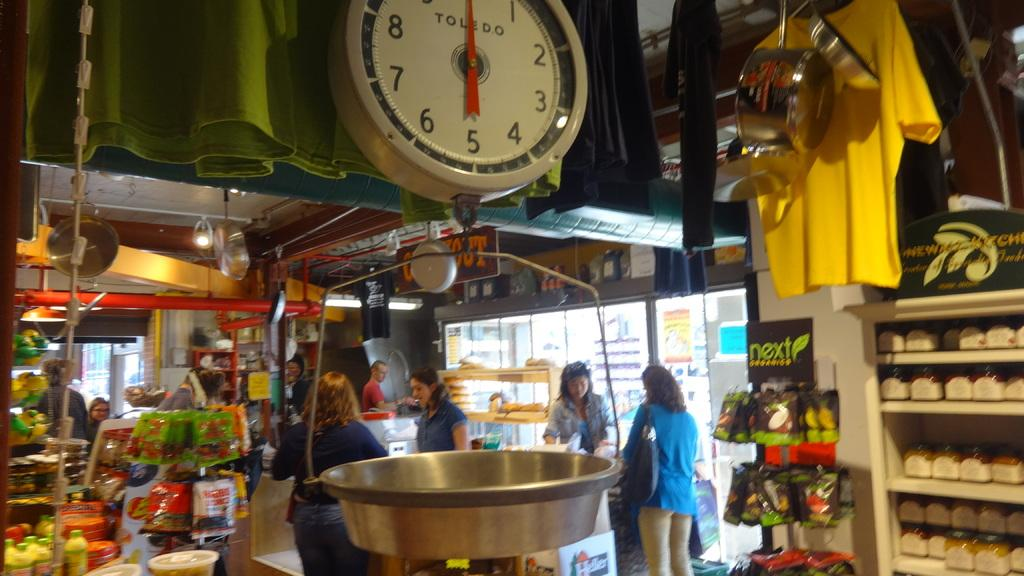<image>
Write a terse but informative summary of the picture. A large scale has the word Toledo on the face of it. 